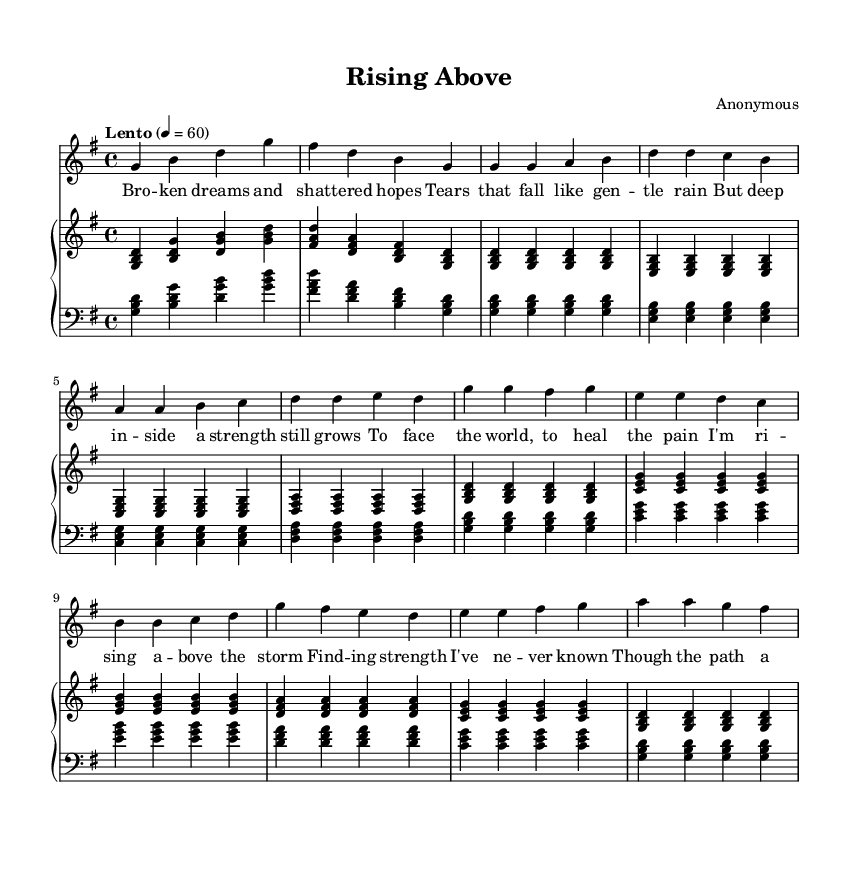What is the key signature of this music? The key signature of this piece is G major, which includes one sharp (F sharp). This is determined from the symbol at the beginning of the staff where one sharp is indicated.
Answer: G major What is the time signature of this music? The time signature is 4/4, indicated at the beginning of the score with a fraction showing there are 4 beats in a measure and the quarter note gets one beat.
Answer: 4/4 What is the tempo marking for the piece? The tempo marking of this piece is "Lento," which indicates a slow tempo. This instruction is noted in the tempo section of the sheet music, guiding the performer on the speed of the piece.
Answer: Lento How many measures are in the chorus section? The chorus section contains 4 measures, as shown with a counting of the individual measures in the score from the start to the end of the chorus section.
Answer: 4 What does the bridge section primarily convey? The bridge section conveys a sense of hope and light, referencing "darkness" and "light" as parts of the lyrics, which suggest an emotional uplift. This can be inferred by analyzing the words and their context in the music.
Answer: Hope and light What does the repeated phrase in the chorus highlight? The repeated phrases in the chorus highlight resilience and community, emphasizing the line "I'll never walk alone," which underscores a theme of finding strength. This is evident from the words in the chorus that convey this sentiment.
Answer: Resilience and community What narrative does the lyric “Through the darkness, I see light” represent in the context of the song? The lyric represents a journey from struggle to strength, indicating personal growth and a recognition of hope, particularly in the visual context of the song's structure where healing is a recurring theme. This reflects a broader narrative of overcoming difficulties, which is evident from both the lyrics and the emotional tone of the music.
Answer: Overcoming difficulties 